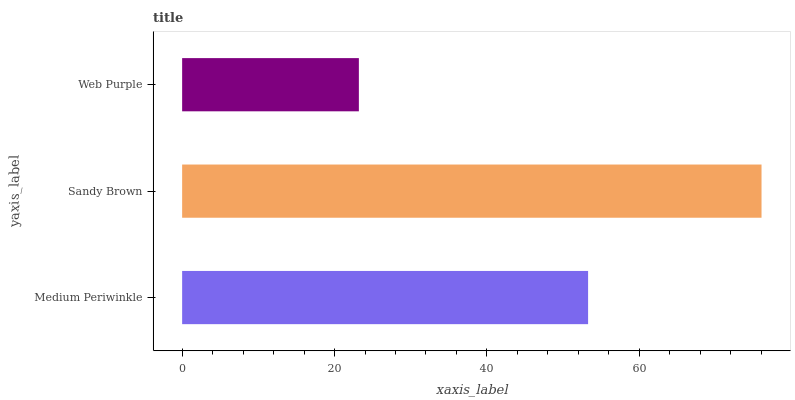Is Web Purple the minimum?
Answer yes or no. Yes. Is Sandy Brown the maximum?
Answer yes or no. Yes. Is Sandy Brown the minimum?
Answer yes or no. No. Is Web Purple the maximum?
Answer yes or no. No. Is Sandy Brown greater than Web Purple?
Answer yes or no. Yes. Is Web Purple less than Sandy Brown?
Answer yes or no. Yes. Is Web Purple greater than Sandy Brown?
Answer yes or no. No. Is Sandy Brown less than Web Purple?
Answer yes or no. No. Is Medium Periwinkle the high median?
Answer yes or no. Yes. Is Medium Periwinkle the low median?
Answer yes or no. Yes. Is Sandy Brown the high median?
Answer yes or no. No. Is Sandy Brown the low median?
Answer yes or no. No. 